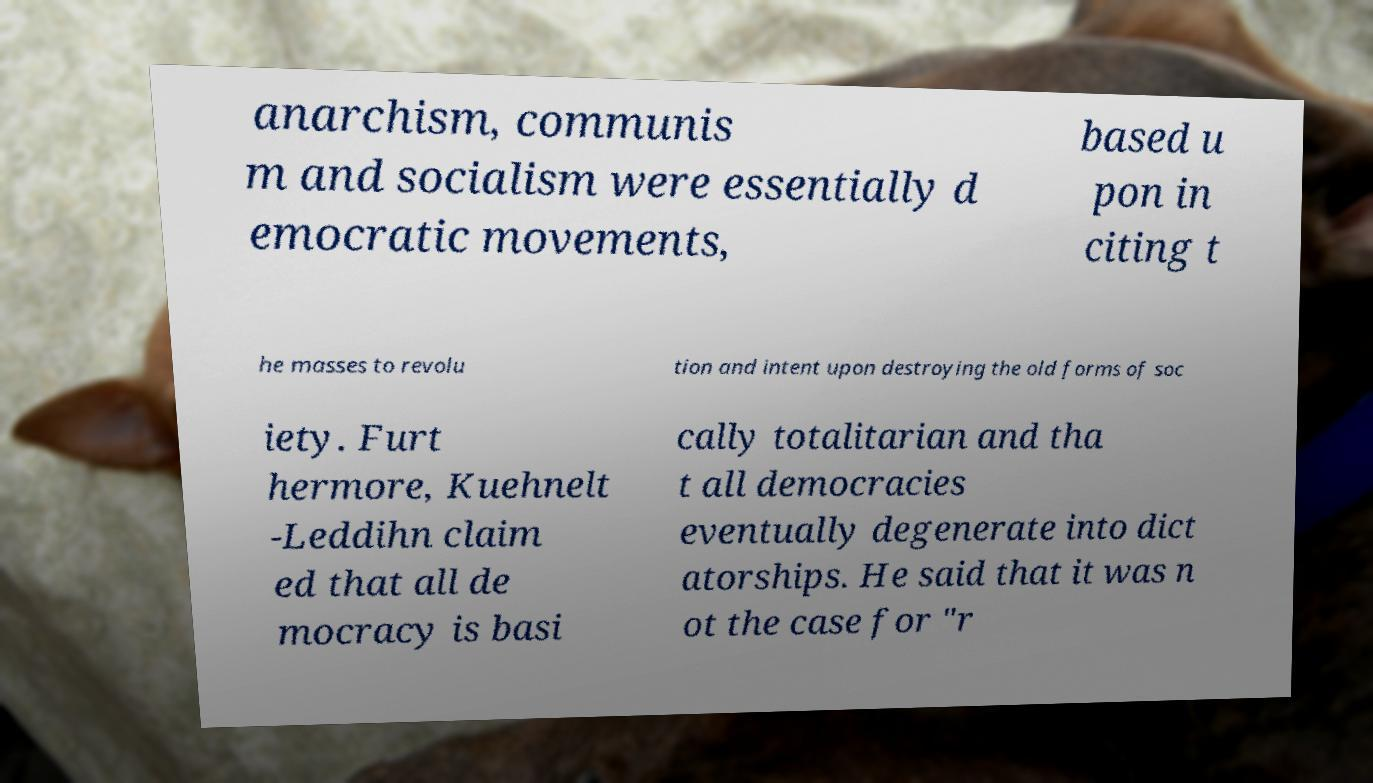For documentation purposes, I need the text within this image transcribed. Could you provide that? anarchism, communis m and socialism were essentially d emocratic movements, based u pon in citing t he masses to revolu tion and intent upon destroying the old forms of soc iety. Furt hermore, Kuehnelt -Leddihn claim ed that all de mocracy is basi cally totalitarian and tha t all democracies eventually degenerate into dict atorships. He said that it was n ot the case for "r 